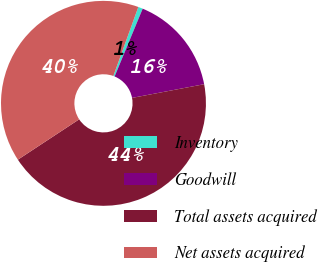Convert chart to OTSL. <chart><loc_0><loc_0><loc_500><loc_500><pie_chart><fcel>Inventory<fcel>Goodwill<fcel>Total assets acquired<fcel>Net assets acquired<nl><fcel>0.73%<fcel>15.76%<fcel>43.73%<fcel>39.79%<nl></chart> 